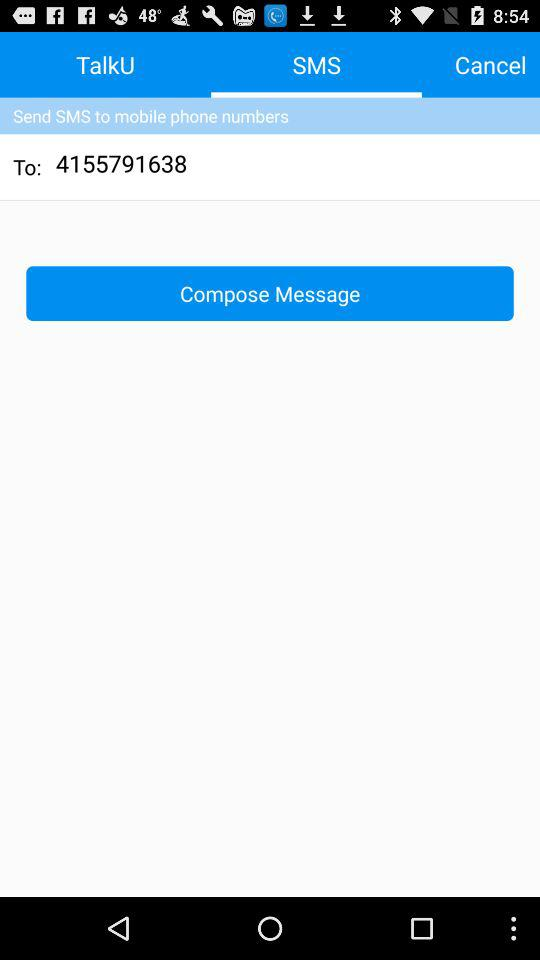Which tab is selected? The selected tab is "SMS". 